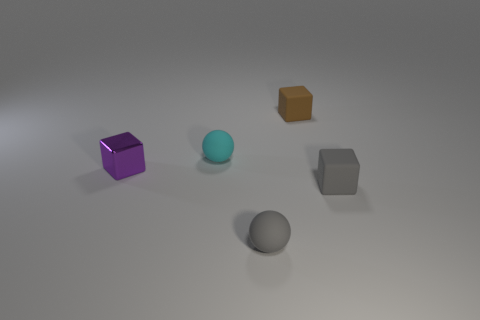Add 2 cyan rubber things. How many objects exist? 7 Subtract all spheres. How many objects are left? 3 Add 5 shiny blocks. How many shiny blocks are left? 6 Add 5 large red shiny cylinders. How many large red shiny cylinders exist? 5 Subtract 0 brown cylinders. How many objects are left? 5 Subtract all purple cubes. Subtract all tiny brown cubes. How many objects are left? 3 